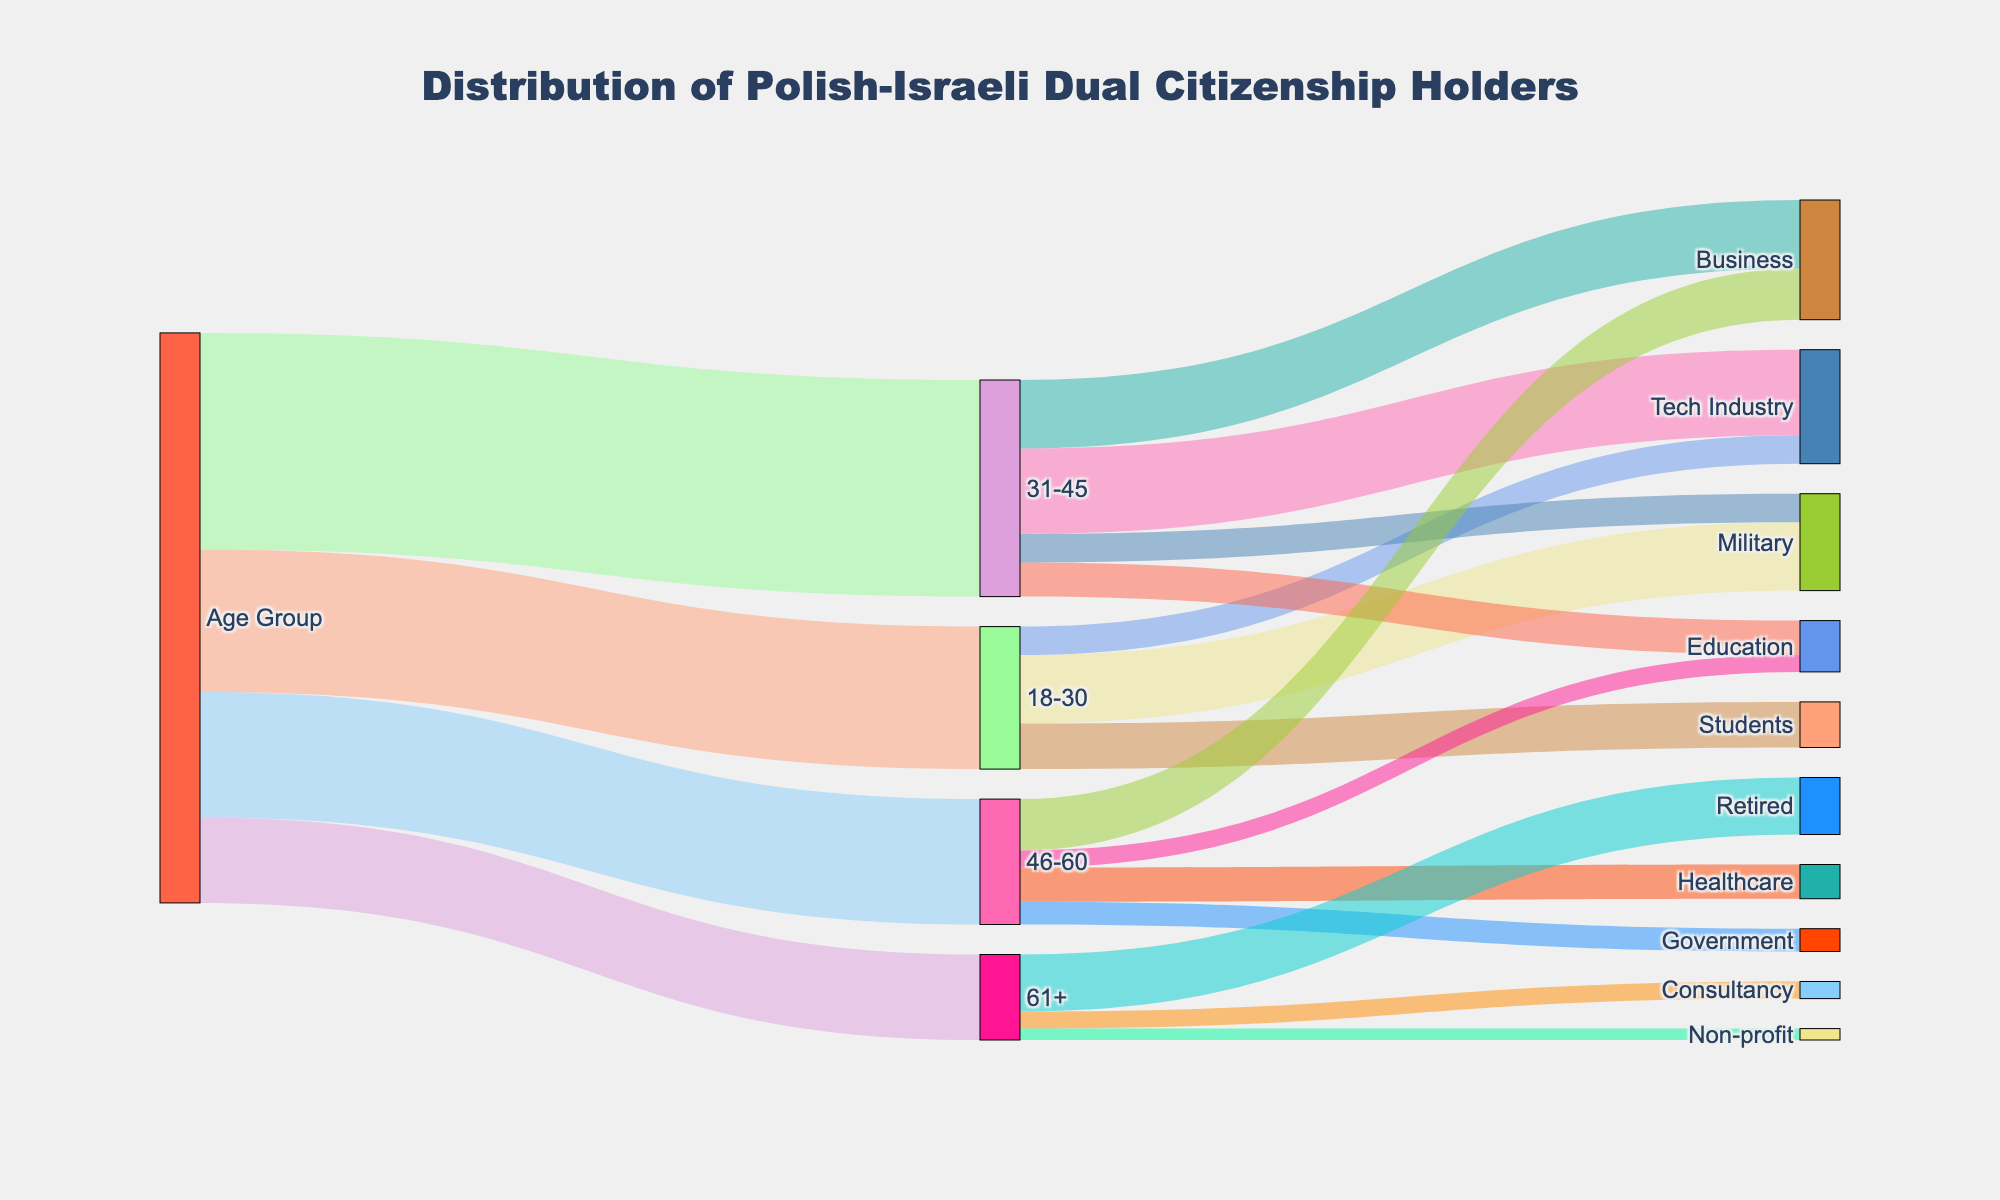What is the total number of Polish-Israeli dual citizenship holders in the 31-45 age group? To find the total number of dual citizenship holders in the 31-45 age group, simply look at the section labeled "31-45" in the Sankey diagram, which indicates the value as 3800.
Answer: 3800 Which profession has the highest number of people in the 18-30 age group? Look at the flows coming out of the "18-30" node and compare the values for each profession. The values are Military (1200), Students (800), and Tech Industry (500). The highest value is for the Military profession.
Answer: Military How many more people in the 61+ age group are retired compared to those in consultancy? Compare the values for Retired and Consultancy in the 61+ age group. Retired has 1000 and Consultancy has 300, so the difference is 1000 - 300 = 700.
Answer: 700 What is the combined number of people in Military from both the 18-30 and 31-45 age groups? Add the values for Military in both age groups: 1200 from the 18-30 group and 500 from the 31-45 group. The sum is 1200 + 500 = 1700.
Answer: 1700 Which age group has the smallest representation in the Business profession? Look at the values for Business in each age group. For 31-45, it is 1200, and for 46-60, it is 900. The age group 61+ has no flow to Business, meaning its representation is 0, which is the smallest.
Answer: 61+ What is the second most common profession for the 46-60 age group? Look at the flows coming out of the "46-60" node. The values are Business (900), Healthcare (600), Government (400), and Education (300). The second highest value is Healthcare with 600.
Answer: Healthcare What is the total number of Polish-Israeli dual citizenship holders across all age groups? Sum the total values from all age groups: 2500 (18-30) + 3800 (31-45) + 2200 (46-60) + 1500 (61+). The sum is 2500 + 3800 + 2200 + 1500 = 10000.
Answer: 10000 How does the number of people in Tech Industry in the 31-45 age group compare to those in the 18-30 age group? Compare the values for Tech Industry in both age groups. For the 31-45 age group, it is 1500, and for the 18-30 age group, it is 500. The 31-45 group has 1500 - 500 = 1000 more people in Tech Industry.
Answer: 1000 more What percentage of the 61+ age group is retired? Divide the number of retired individuals by the total number in the 61+ age group, and multiply by 100 to get the percentage: (1000 / 1500) * 100 = 66.67%.
Answer: 66.67% How many people are in non-military professions in the 31-45 age group? Subtract the number in Military from the total in the 31-45 age group: 3800 - 500 = 3300.
Answer: 3300 